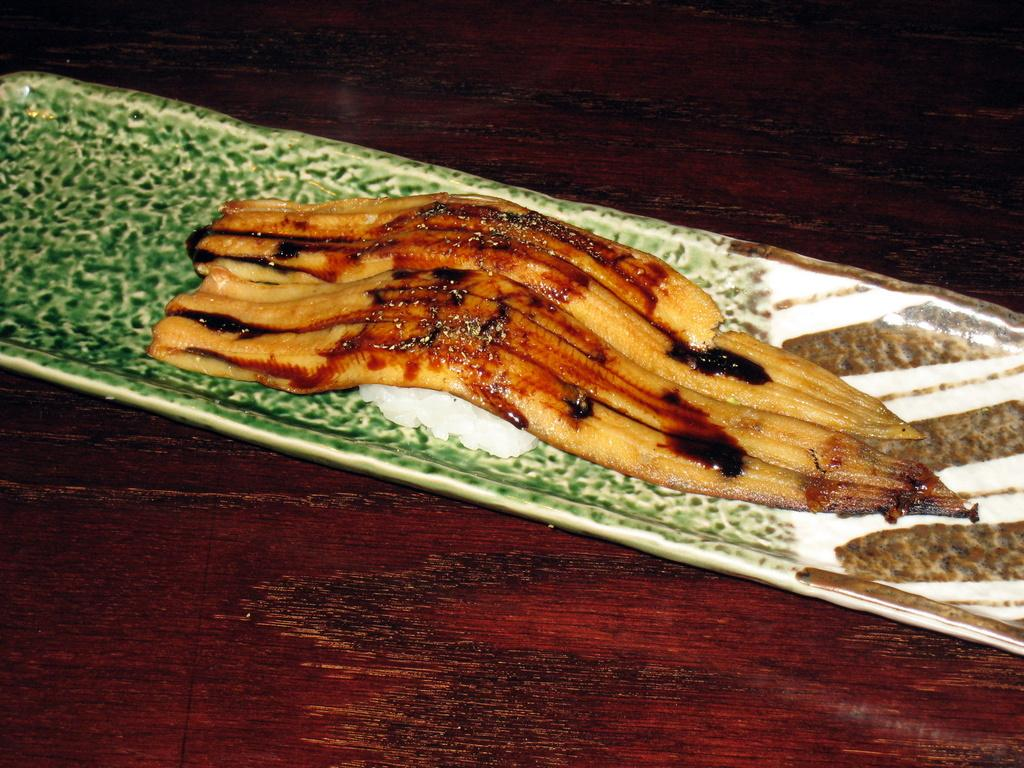What object is present in the image that can hold food? There is a saucer in the image that can hold food. What is on the saucer? The saucer contains a food item. Where is the saucer located? The saucer is placed on a table. How many babies are visible in the image? There are no babies present in the image. What type of feet can be seen in the image? There are no feet visible in the image. 